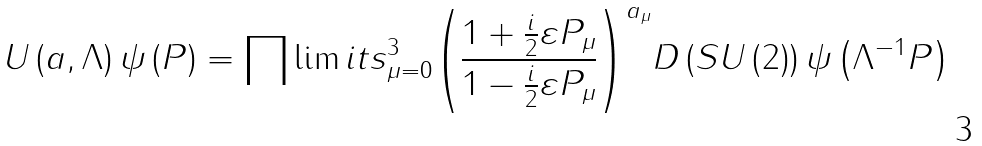<formula> <loc_0><loc_0><loc_500><loc_500>U \left ( { a , \Lambda } \right ) \psi \left ( { P } \right ) = \prod \lim i t s _ { \mu = 0 } ^ { 3 } { \left ( { { \frac { 1 + { \frac { i } { 2 } } \varepsilon { P } _ { \mu } } { 1 - { \frac { i } { 2 } } \varepsilon { P } _ { \mu } } } } \right ) } ^ { { a } _ { \mu } } D \left ( { S U \left ( { 2 } \right ) } \right ) \psi \left ( { { \Lambda } ^ { - 1 } P } \right )</formula> 